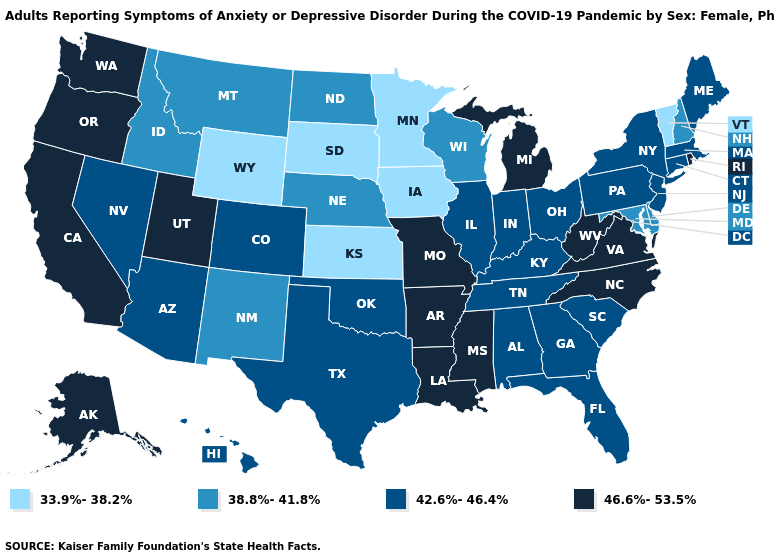Does Arizona have the lowest value in the West?
Quick response, please. No. Does Alabama have the lowest value in the USA?
Answer briefly. No. Does New Hampshire have the same value as New Mexico?
Quick response, please. Yes. What is the highest value in the USA?
Write a very short answer. 46.6%-53.5%. Does Iowa have the lowest value in the MidWest?
Keep it brief. Yes. Does the map have missing data?
Quick response, please. No. Is the legend a continuous bar?
Be succinct. No. Name the states that have a value in the range 42.6%-46.4%?
Short answer required. Alabama, Arizona, Colorado, Connecticut, Florida, Georgia, Hawaii, Illinois, Indiana, Kentucky, Maine, Massachusetts, Nevada, New Jersey, New York, Ohio, Oklahoma, Pennsylvania, South Carolina, Tennessee, Texas. Does South Carolina have a higher value than Vermont?
Concise answer only. Yes. What is the lowest value in states that border Missouri?
Short answer required. 33.9%-38.2%. What is the value of Nebraska?
Answer briefly. 38.8%-41.8%. Among the states that border Iowa , does Missouri have the highest value?
Quick response, please. Yes. Name the states that have a value in the range 38.8%-41.8%?
Answer briefly. Delaware, Idaho, Maryland, Montana, Nebraska, New Hampshire, New Mexico, North Dakota, Wisconsin. Which states have the lowest value in the South?
Write a very short answer. Delaware, Maryland. Among the states that border Alabama , does Mississippi have the lowest value?
Give a very brief answer. No. 